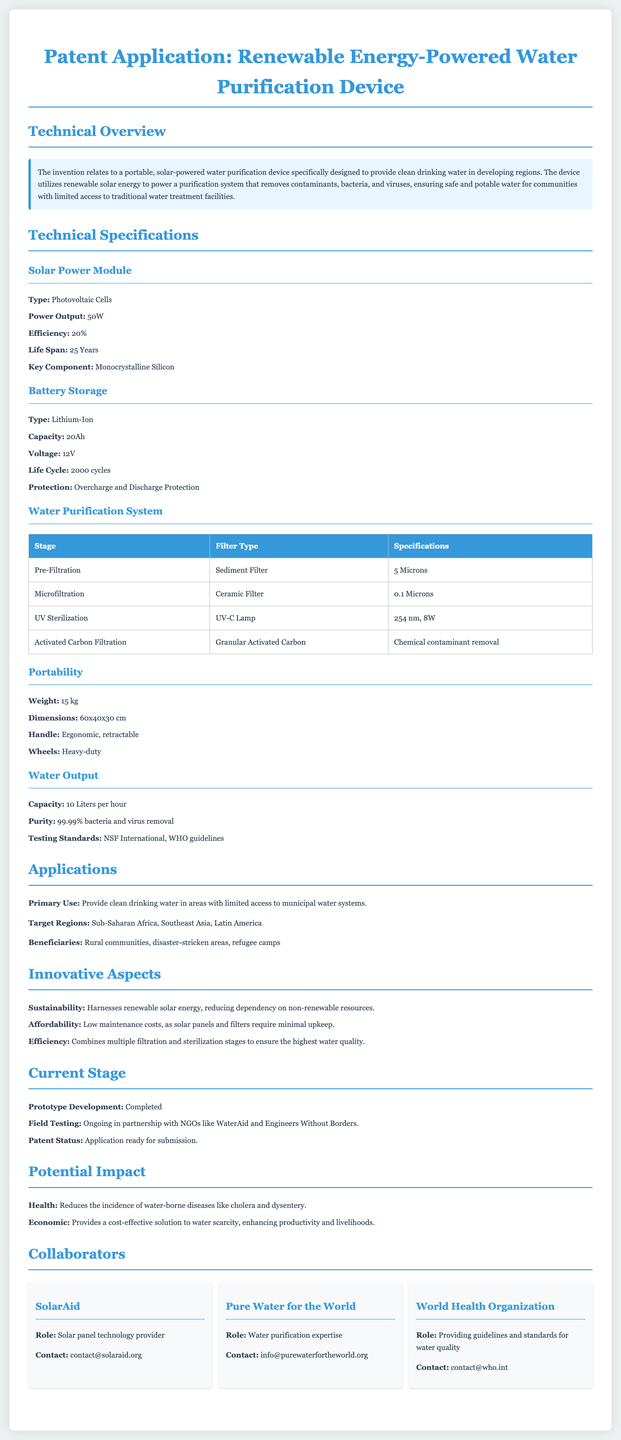What is the power output of the solar power module? The power output is specified in the Technical Specifications section under Solar Power Module, which is 50W.
Answer: 50W What is the type of the battery storage used in the device? The type of battery storage is listed in the Technical Specifications section under Battery Storage as Lithium-Ion.
Answer: Lithium-Ion What is the maximum water output capacity of the device? The capacity is mentioned in the Water Output section, which states it can purify 10 liters per hour.
Answer: 10 Liters per hour Which organizations are currently involved in field testing? The organizations are listed in the Current Stage section, specifically noted as NGOs like WaterAid and Engineers Without Borders.
Answer: WaterAid and Engineers Without Borders What is the main target region for this water purification device? The primary target regions are noted in the Applications section as Sub-Saharan Africa, Southeast Asia, and Latin America.
Answer: Sub-Saharan Africa, Southeast Asia, Latin America What is the life cycle of the lithium-ion battery? The life cycle is detailed in the Technical Specifications section under Battery Storage as 2000 cycles.
Answer: 2000 cycles What is the purity level of water after treatment? The purity level is specified in the Water Output section, stating it achieves 99.99% bacteria and virus removal.
Answer: 99.99% What innovative aspect reduces dependency on non-renewable resources? The innovative aspect mentioned in the Innovative Aspects section is its sustainability due to harnessing renewable solar energy.
Answer: Sustainability 